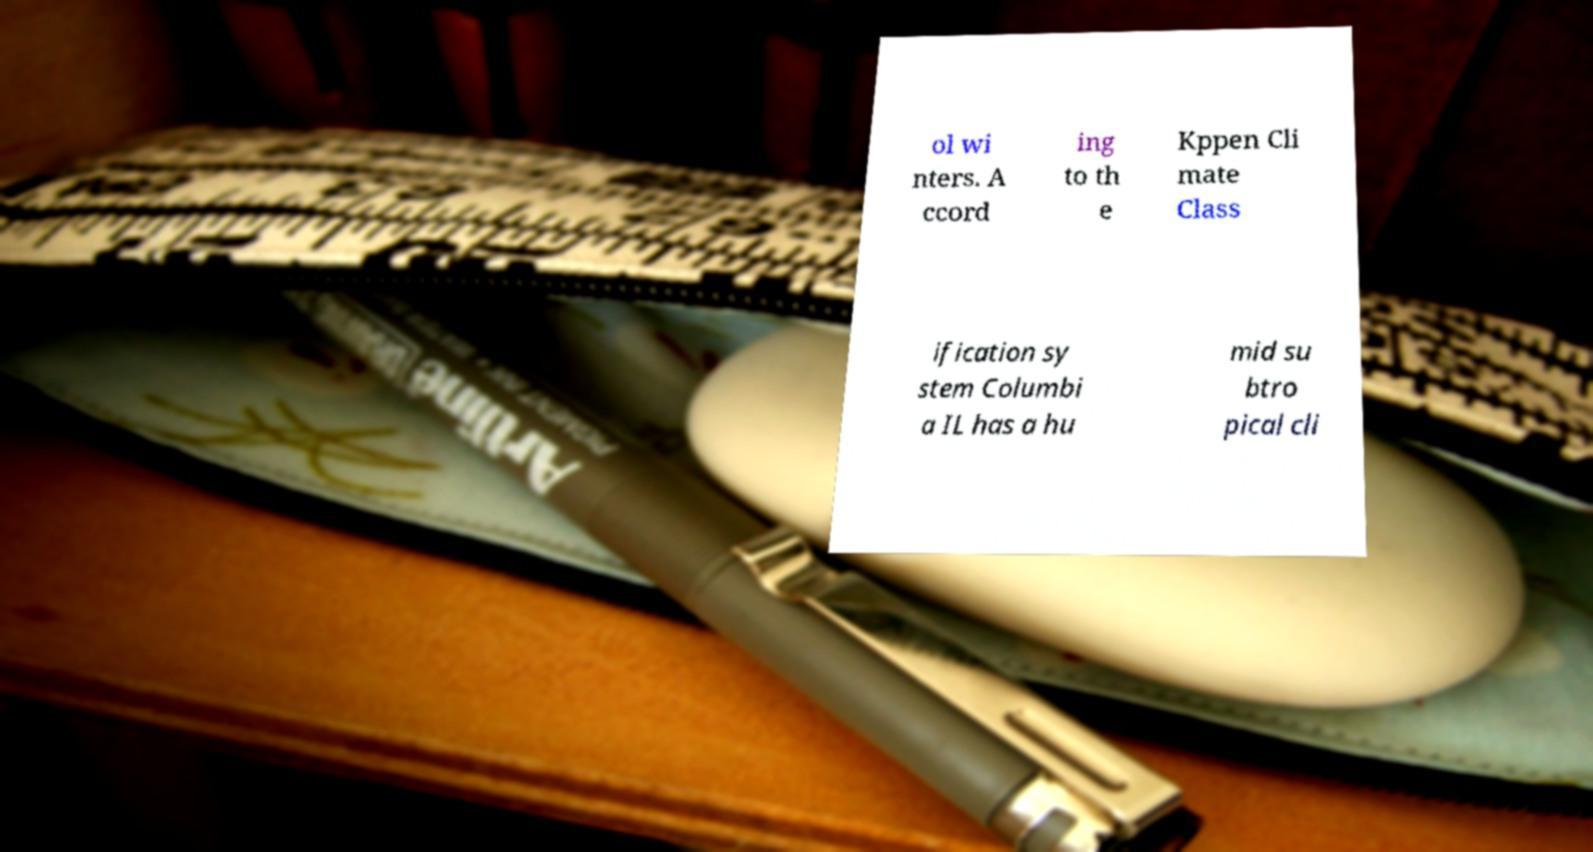I need the written content from this picture converted into text. Can you do that? ol wi nters. A ccord ing to th e Kppen Cli mate Class ification sy stem Columbi a IL has a hu mid su btro pical cli 